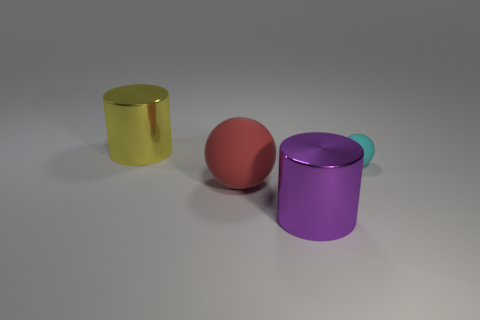Add 2 big balls. How many objects exist? 6 Subtract all tiny cyan cubes. Subtract all large yellow metal objects. How many objects are left? 3 Add 2 large purple cylinders. How many large purple cylinders are left? 3 Add 4 big brown matte cylinders. How many big brown matte cylinders exist? 4 Subtract 0 blue blocks. How many objects are left? 4 